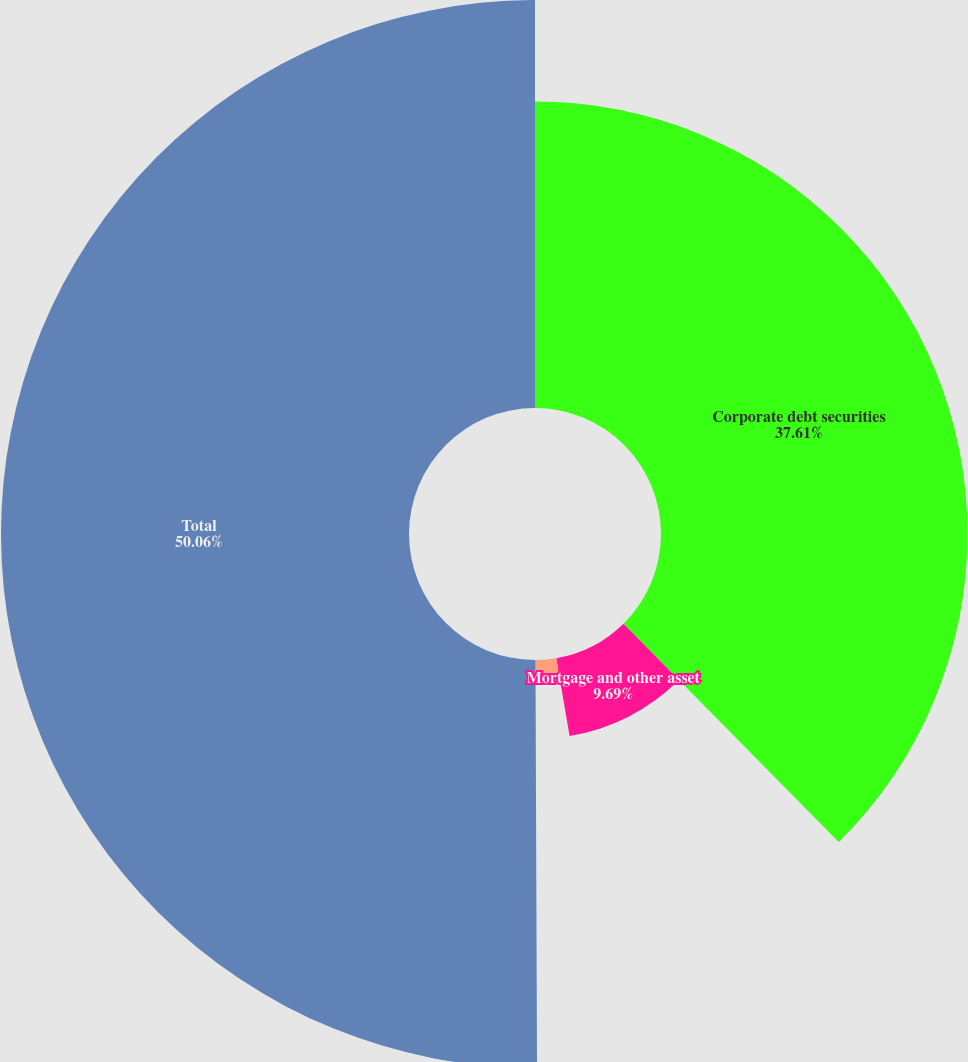Convert chart to OTSL. <chart><loc_0><loc_0><loc_500><loc_500><pie_chart><fcel>Corporate debt securities<fcel>Mortgage and other asset<fcel>State and municipal<fcel>Total<nl><fcel>37.61%<fcel>9.69%<fcel>2.64%<fcel>50.06%<nl></chart> 